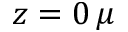Convert formula to latex. <formula><loc_0><loc_0><loc_500><loc_500>z = 0 \, \mu</formula> 